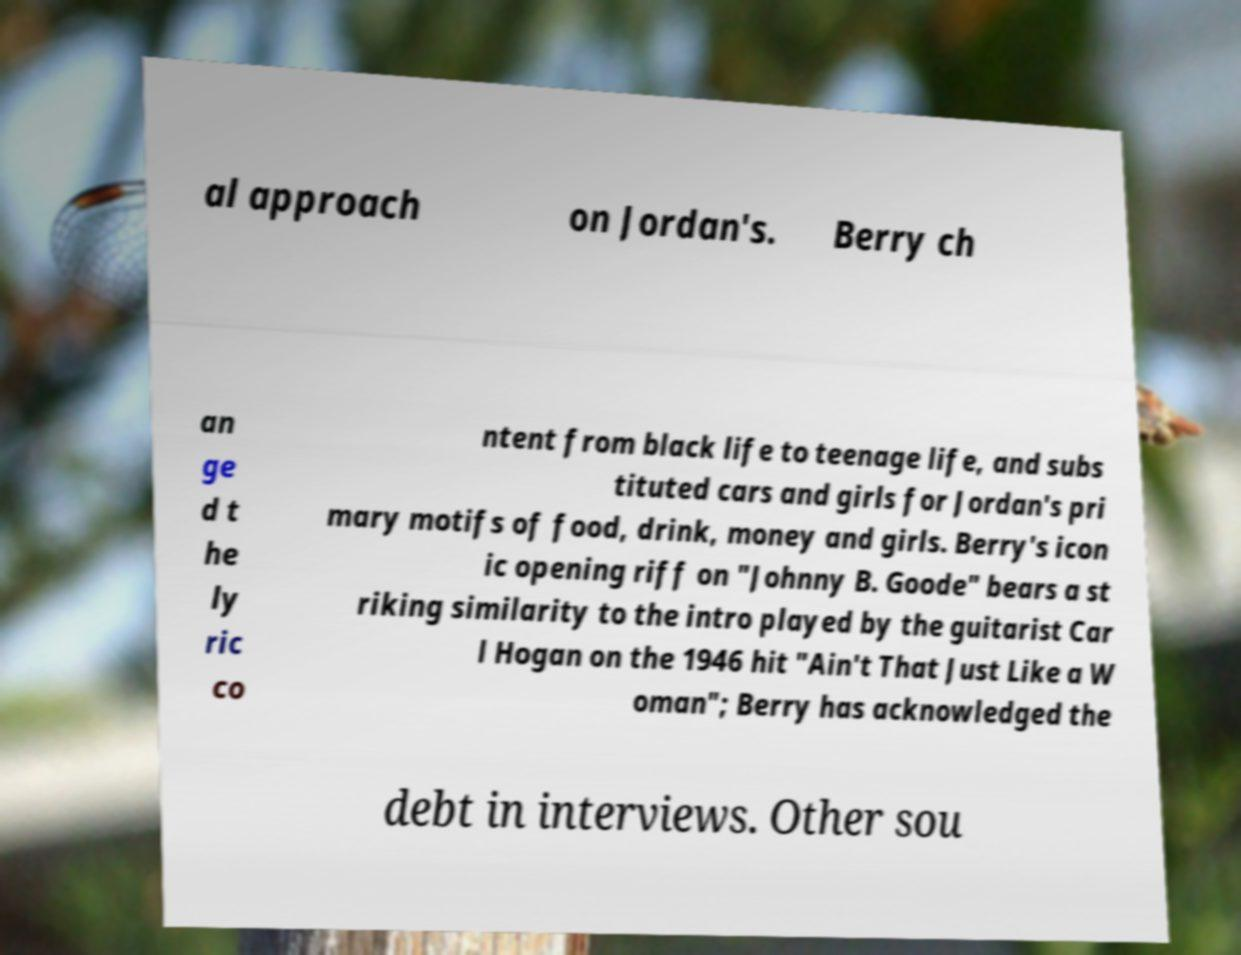Can you read and provide the text displayed in the image?This photo seems to have some interesting text. Can you extract and type it out for me? al approach on Jordan's. Berry ch an ge d t he ly ric co ntent from black life to teenage life, and subs tituted cars and girls for Jordan's pri mary motifs of food, drink, money and girls. Berry's icon ic opening riff on "Johnny B. Goode" bears a st riking similarity to the intro played by the guitarist Car l Hogan on the 1946 hit "Ain't That Just Like a W oman"; Berry has acknowledged the debt in interviews. Other sou 